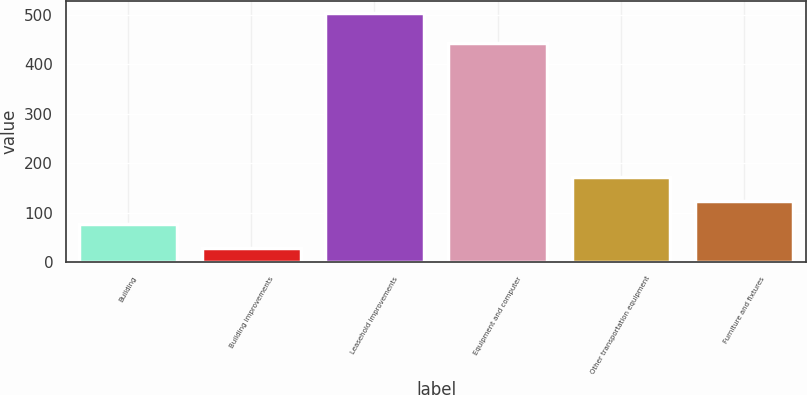<chart> <loc_0><loc_0><loc_500><loc_500><bar_chart><fcel>Building<fcel>Building improvements<fcel>Leasehold improvements<fcel>Equipment and computer<fcel>Other transportation equipment<fcel>Furniture and fixtures<nl><fcel>76.5<fcel>29<fcel>504<fcel>444<fcel>171.5<fcel>124<nl></chart> 